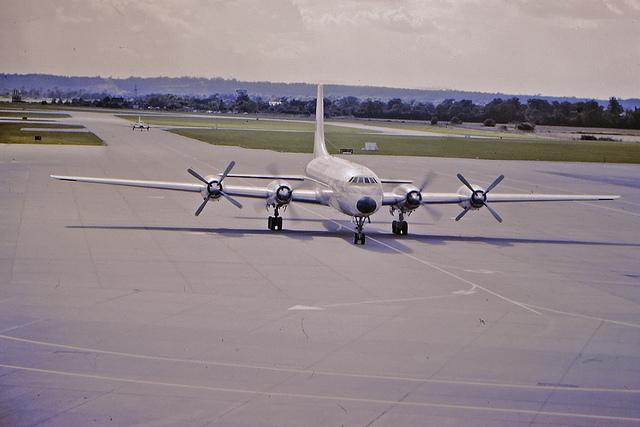Where is the vehicle located? Please explain your reasoning. runway. The plane is parked on a runway so it can take off for its destination. 